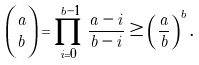<formula> <loc_0><loc_0><loc_500><loc_500>\binom { a } { b } = \prod _ { i = 0 } ^ { b - 1 } \frac { a - i } { b - i } \geq \left ( \frac { a } { b } \right ) ^ { b } .</formula> 